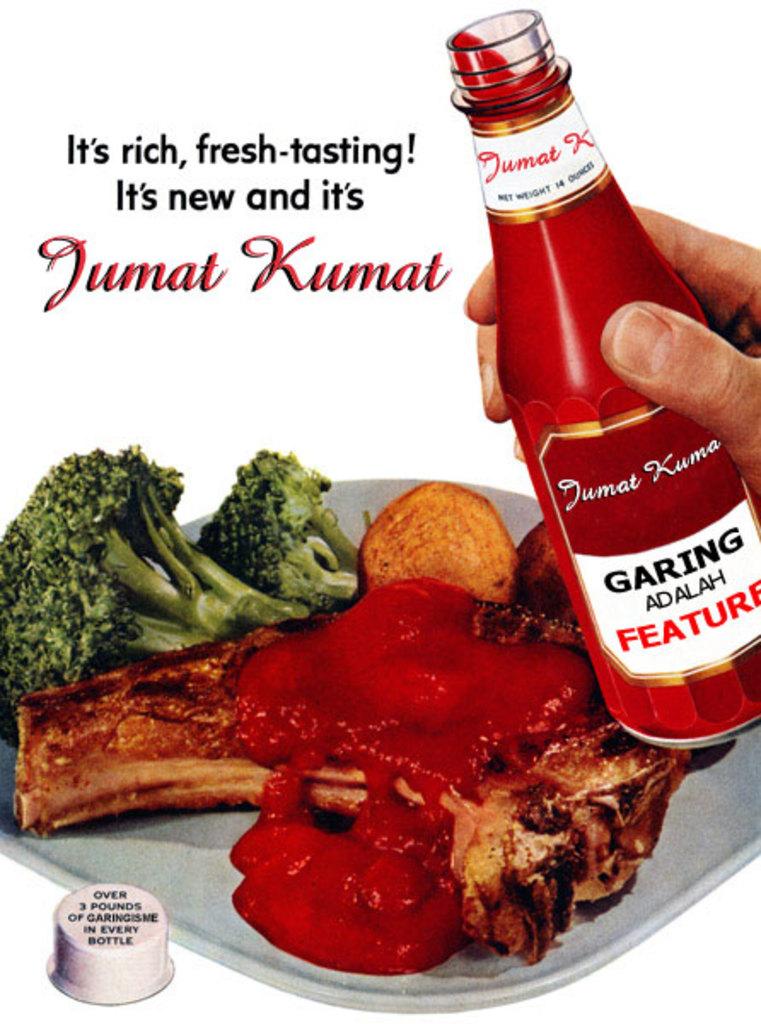What kind of sauce is that?
Offer a very short reply. Jumat kumat. What brand is the sauce?
Make the answer very short. Jumat kumat. 